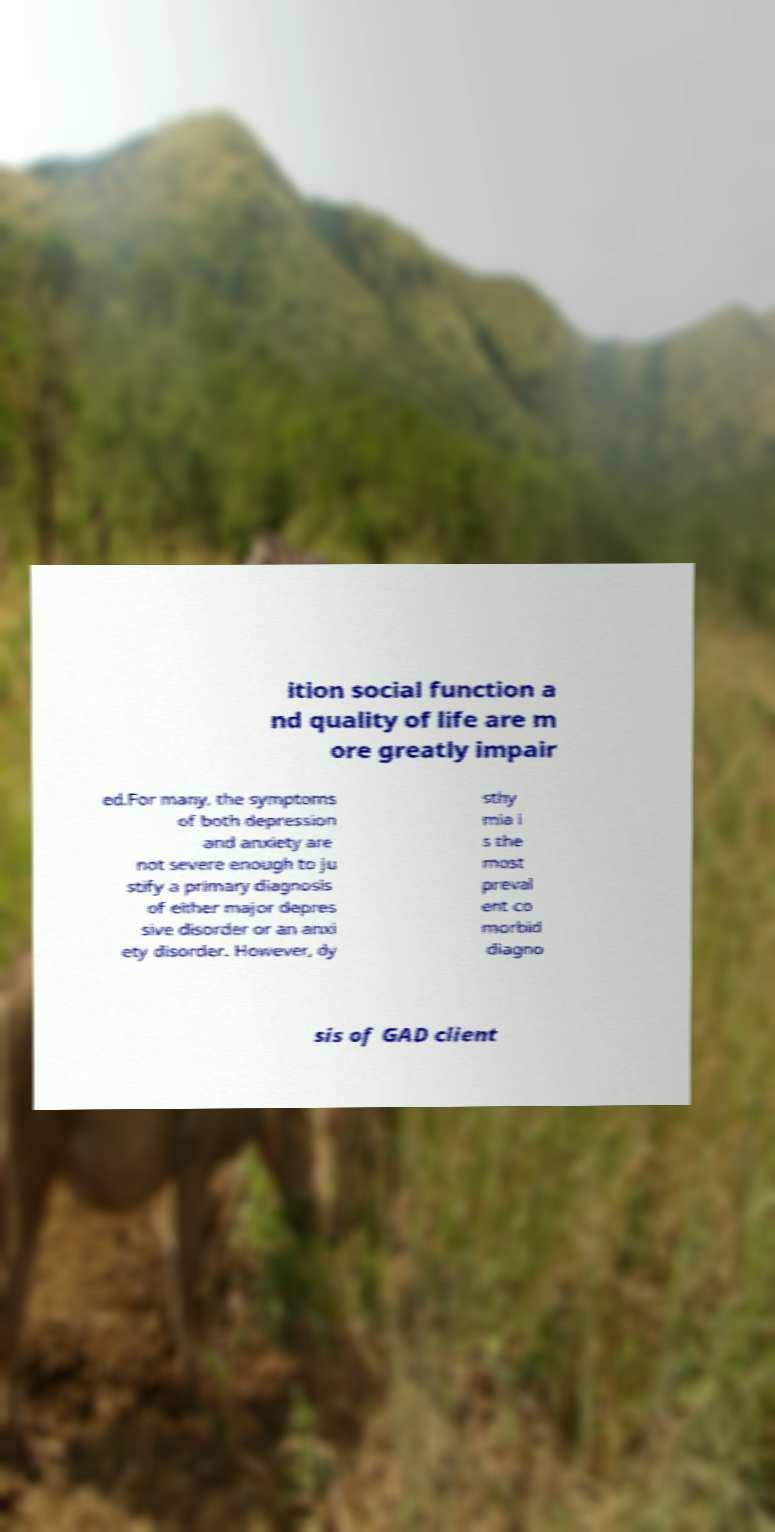I need the written content from this picture converted into text. Can you do that? ition social function a nd quality of life are m ore greatly impair ed.For many, the symptoms of both depression and anxiety are not severe enough to ju stify a primary diagnosis of either major depres sive disorder or an anxi ety disorder. However, dy sthy mia i s the most preval ent co morbid diagno sis of GAD client 